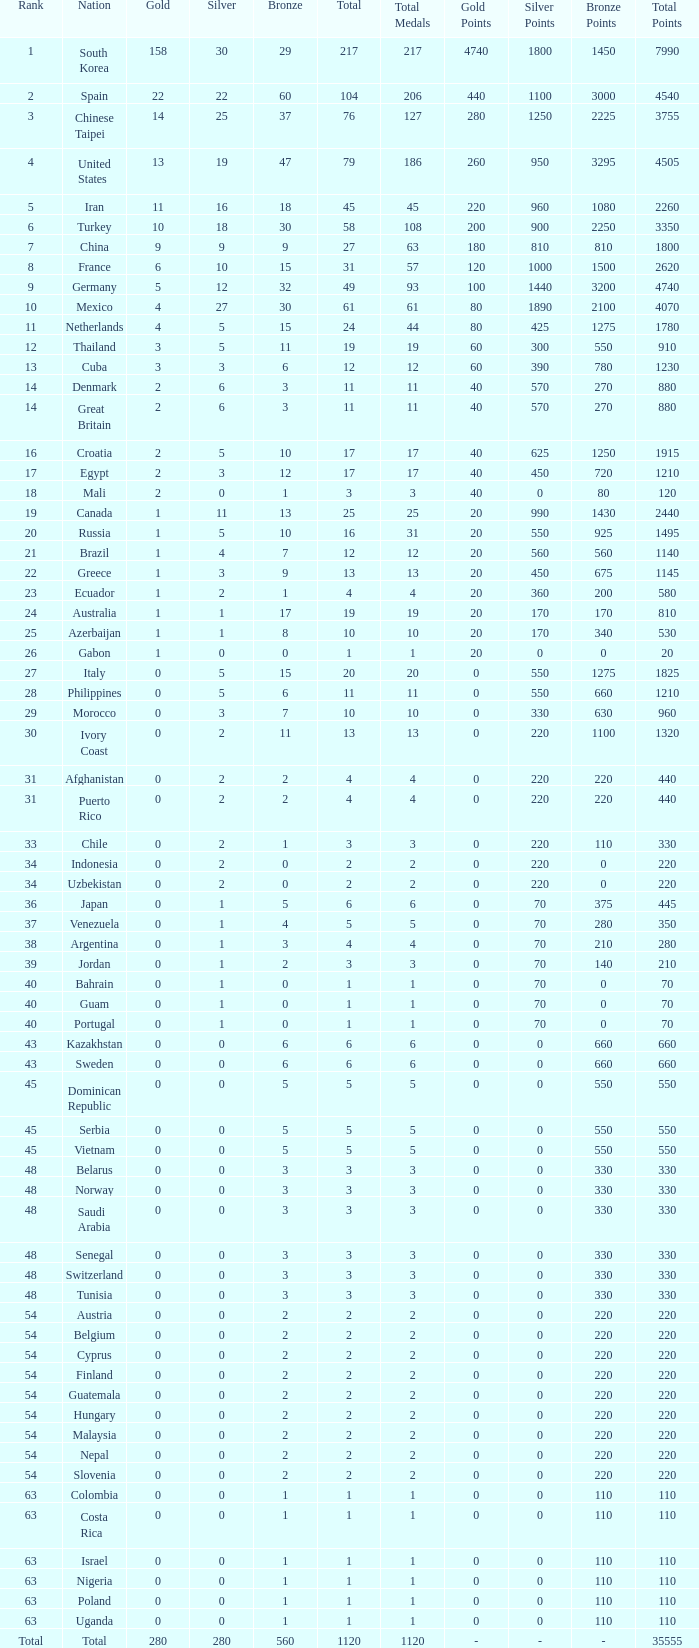What is the Total medals for the Nation ranking 33 with more than 1 Bronze? None. 